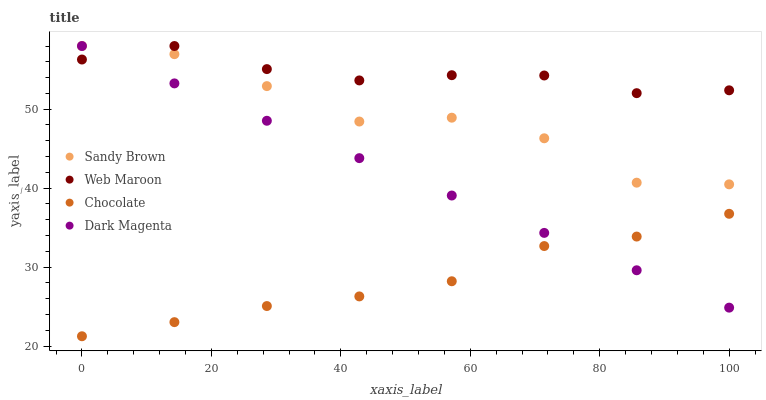Does Chocolate have the minimum area under the curve?
Answer yes or no. Yes. Does Web Maroon have the maximum area under the curve?
Answer yes or no. Yes. Does Sandy Brown have the minimum area under the curve?
Answer yes or no. No. Does Sandy Brown have the maximum area under the curve?
Answer yes or no. No. Is Dark Magenta the smoothest?
Answer yes or no. Yes. Is Sandy Brown the roughest?
Answer yes or no. Yes. Is Sandy Brown the smoothest?
Answer yes or no. No. Is Dark Magenta the roughest?
Answer yes or no. No. Does Chocolate have the lowest value?
Answer yes or no. Yes. Does Sandy Brown have the lowest value?
Answer yes or no. No. Does Dark Magenta have the highest value?
Answer yes or no. Yes. Does Chocolate have the highest value?
Answer yes or no. No. Is Chocolate less than Sandy Brown?
Answer yes or no. Yes. Is Sandy Brown greater than Chocolate?
Answer yes or no. Yes. Does Web Maroon intersect Dark Magenta?
Answer yes or no. Yes. Is Web Maroon less than Dark Magenta?
Answer yes or no. No. Is Web Maroon greater than Dark Magenta?
Answer yes or no. No. Does Chocolate intersect Sandy Brown?
Answer yes or no. No. 